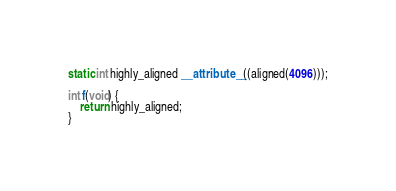Convert code to text. <code><loc_0><loc_0><loc_500><loc_500><_C_>
static int highly_aligned __attribute__((aligned(4096)));

int f(void) {
	return highly_aligned;
}
</code> 